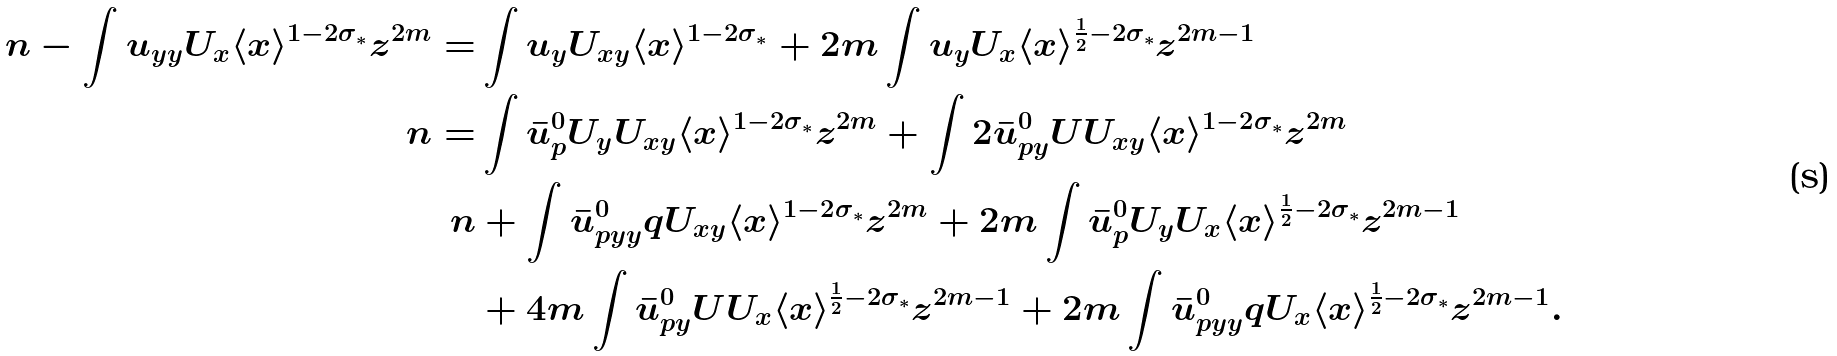Convert formula to latex. <formula><loc_0><loc_0><loc_500><loc_500>\ n - \int u _ { y y } U _ { x } \langle x \rangle ^ { 1 - 2 \sigma _ { \ast } } z ^ { 2 m } = & \int u _ { y } U _ { x y } \langle x \rangle ^ { 1 - 2 \sigma _ { \ast } } + 2 m \int u _ { y } U _ { x } \langle x \rangle ^ { \frac { 1 } { 2 } - 2 \sigma _ { \ast } } z ^ { 2 m - 1 } \\ \ n = & \int \bar { u } ^ { 0 } _ { p } U _ { y } U _ { x y } \langle x \rangle ^ { 1 - 2 \sigma _ { \ast } } z ^ { 2 m } + \int 2 \bar { u } ^ { 0 } _ { p y } U U _ { x y } \langle x \rangle ^ { 1 - 2 \sigma _ { \ast } } z ^ { 2 m } \\ \ n & + \int \bar { u } ^ { 0 } _ { p y y } q U _ { x y } \langle x \rangle ^ { 1 - 2 \sigma _ { \ast } } z ^ { 2 m } + 2 m \int \bar { u } ^ { 0 } _ { p } U _ { y } U _ { x } \langle x \rangle ^ { \frac { 1 } { 2 } - 2 \sigma _ { \ast } } z ^ { 2 m - 1 } \\ & + 4 m \int \bar { u } ^ { 0 } _ { p y } U U _ { x } \langle x \rangle ^ { \frac { 1 } { 2 } - 2 \sigma _ { \ast } } z ^ { 2 m - 1 } + 2 m \int \bar { u } ^ { 0 } _ { p y y } q U _ { x } \langle x \rangle ^ { \frac { 1 } { 2 } - 2 \sigma _ { \ast } } z ^ { 2 m - 1 } .</formula> 